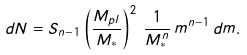Convert formula to latex. <formula><loc_0><loc_0><loc_500><loc_500>d N = S _ { n - 1 } \left ( \frac { M _ { p l } } { M _ { * } } \right ) ^ { 2 } \, \frac { 1 } { M _ { * } ^ { n } } \, m ^ { n - 1 } \, d m .</formula> 